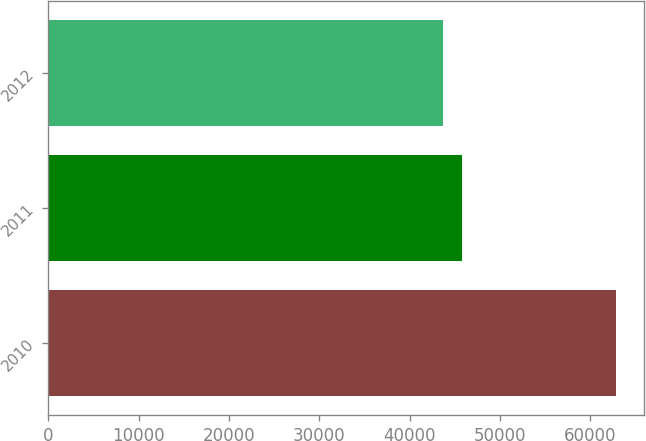Convert chart to OTSL. <chart><loc_0><loc_0><loc_500><loc_500><bar_chart><fcel>2010<fcel>2011<fcel>2012<nl><fcel>62809<fcel>45755<fcel>43705<nl></chart> 